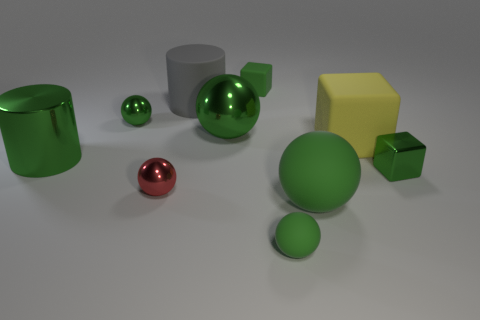There is a large rubber object that is both in front of the large rubber cylinder and on the left side of the yellow matte object; what color is it?
Provide a short and direct response. Green. Do the matte cylinder and the red metallic ball to the left of the big yellow matte object have the same size?
Offer a terse response. No. What is the shape of the small green rubber thing in front of the red ball?
Ensure brevity in your answer.  Sphere. Is there anything else that has the same material as the red thing?
Provide a short and direct response. Yes. Are there more yellow rubber blocks behind the green matte block than shiny spheres?
Your response must be concise. No. There is a green shiny object left of the small green sphere behind the red object; how many cylinders are behind it?
Offer a very short reply. 1. Do the green matte object behind the yellow matte thing and the metal sphere that is to the right of the rubber cylinder have the same size?
Make the answer very short. No. What material is the green object to the left of the tiny green shiny object behind the large yellow cube made of?
Provide a succinct answer. Metal. How many objects are either shiny objects to the right of the gray rubber cylinder or small rubber objects?
Provide a succinct answer. 4. Is the number of metal balls that are in front of the large metallic ball the same as the number of rubber cylinders that are in front of the tiny green matte sphere?
Offer a very short reply. No. 